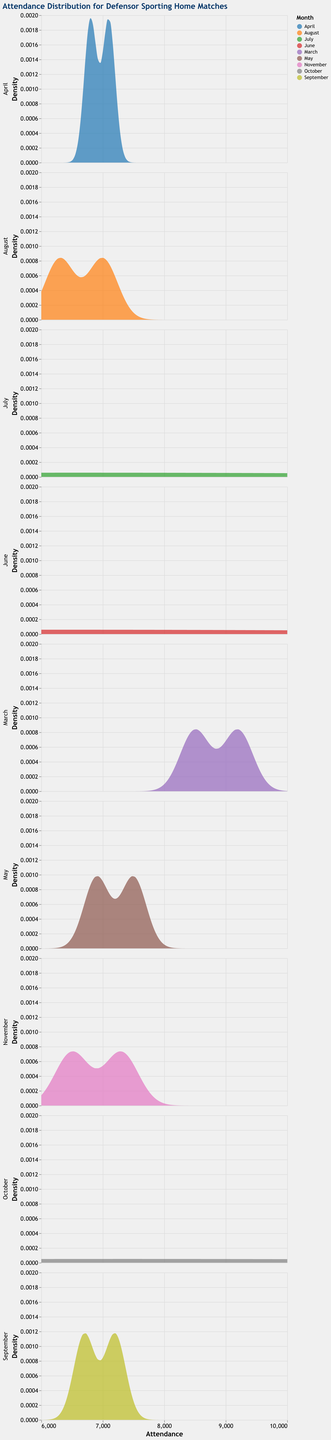What is the title of the plot? The title of the plot is displayed at the top of the figure.
Answer: Attendance Distribution for Defensor Sporting Home Matches What are the units of the x-axis in the density plots? The x-axis represents attendance figures for the matches, labeled as "Attendance".
Answer: Attendance How is the attendance for matches in April distributed compared to that in July? By looking at the density plots for April and July, we can see the spread and peaks of attendance figures. If the density curve for April is more spread out and lower, while the July curve is more sharply peaked, we conclude that April has a more varied attendance while July has a more consistent but lower attendance.
Answer: April is more varied; July is consistent but lower Which month has the highest density peak? Check each subplot to see which one has the highest peak on the density (y-axis). The highest peak indicates the highest concentration of attendance figures around a certain value.
Answer: March What is the range of attendance considered in the density plots? The density plots have an x-axis range that specifies the attendance figures, visible as the extent of the x-axis from minimum to maximum values.
Answer: 6000 to 10000 Between which months does the attendance have the least variability? Look at the density curves and determine which month has the narrowest spread of peaks. A narrow spread indicates less variability in attendance.
Answer: October Which months show attendance figures peaking between 7000 and 7500? Identify which density plots have peaks that fall within the 7000 to 7500 range on the x-axis.
Answer: May and October How would you describe the attendance trend in August? Examine the density plot for August to determine the shape and spread of the curve, which indicates the distribution of attendance figures.
Answer: Lower and slightly varied around 6300 to 7000 Compare the attendance distributions for March and November. What important differences can you infer? Review the density plots for both March and November, focusing on the shape, spread, and peak of each month's distribution. March may have higher peaks and more spread based on strong opponents like Nacional and Peñarol, while November has a more varied attendance.
Answer: March is higher and focused, November is varied In which month is the attendance density the most widely spread out? Look for the month where the density plot is the most spread out along the attendance range, indicating a wide variability in attendance figures.
Answer: September 